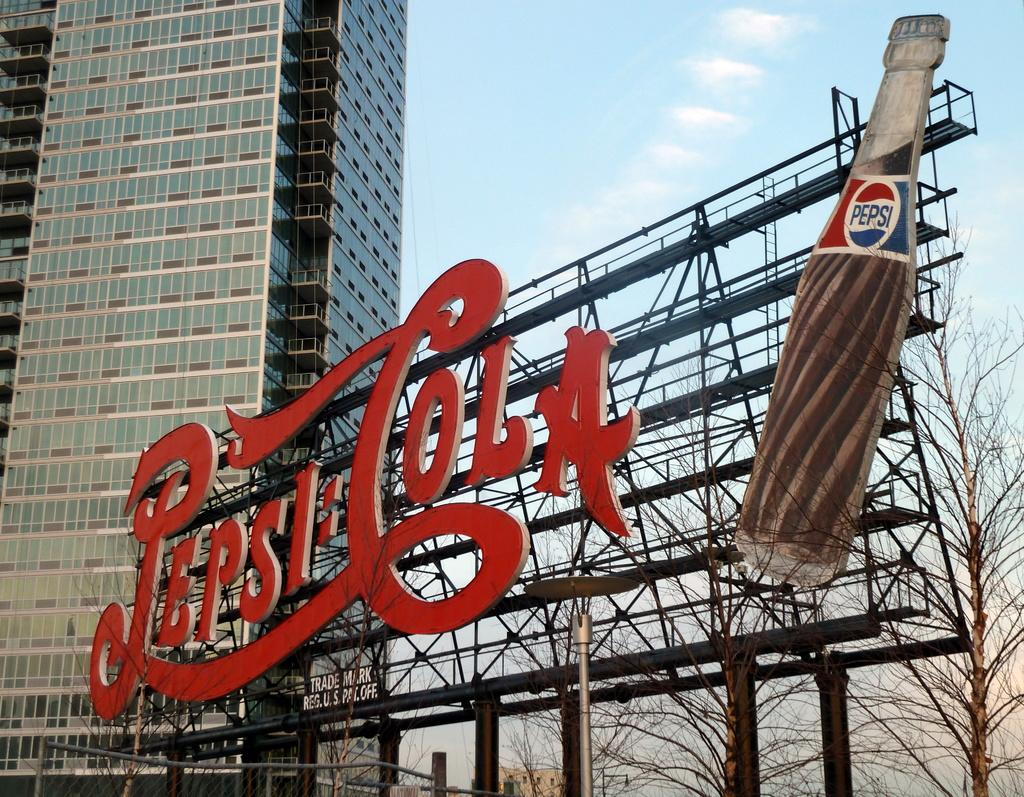What type of structures can be seen in the image? There are buildings in the image. What kind of vegetation is present in the image? Dry trees are present in the image. What object can be seen in the image that might be used for displaying information? There is a board in the image. What is visible in the image that might be used for drinking? A bottle is visible in the image. What is written on the board in the image? Something is written on the board in the image. What is the color of the sky in the image? The sky is blue and white in color. How many pizzas are being served by the minister in the image? There are no pizzas or minister present in the image. Can you tell me how many times the person sneezes in the image? There is no person sneezing in the image. 